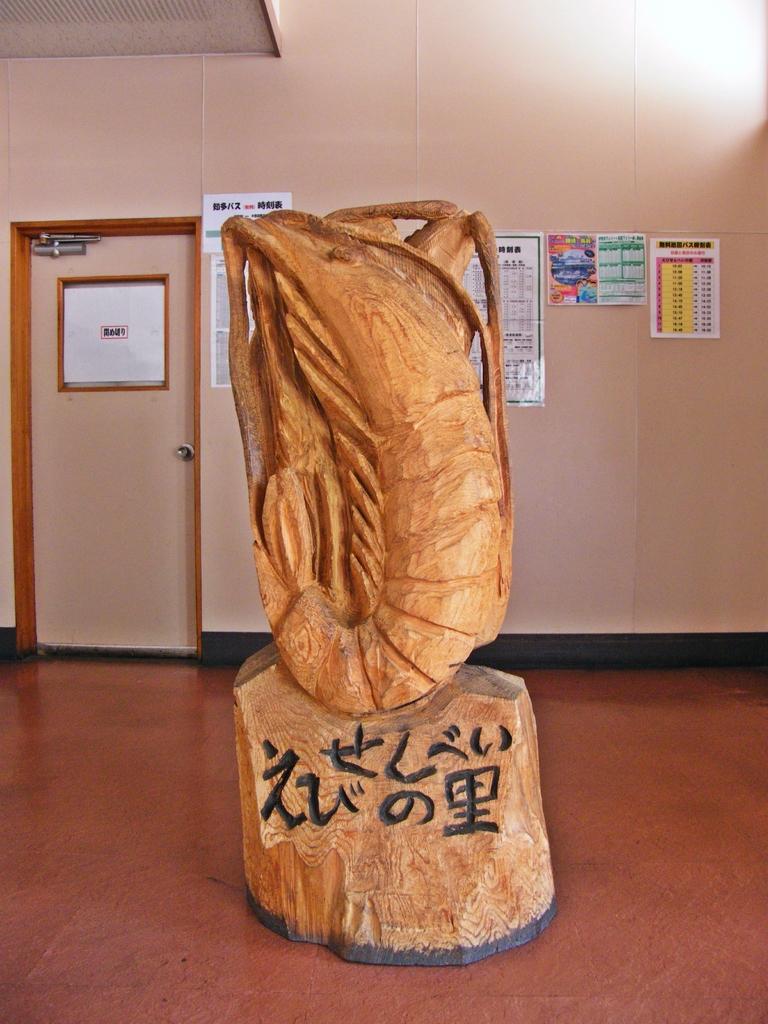Is the label on the sculpture written in a foreign language?
Offer a terse response. Yes. 